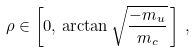Convert formula to latex. <formula><loc_0><loc_0><loc_500><loc_500>\rho \in \left [ 0 , \, \arctan \sqrt { \frac { - m _ { u } } { m _ { c } } } \, \right ] \, ,</formula> 